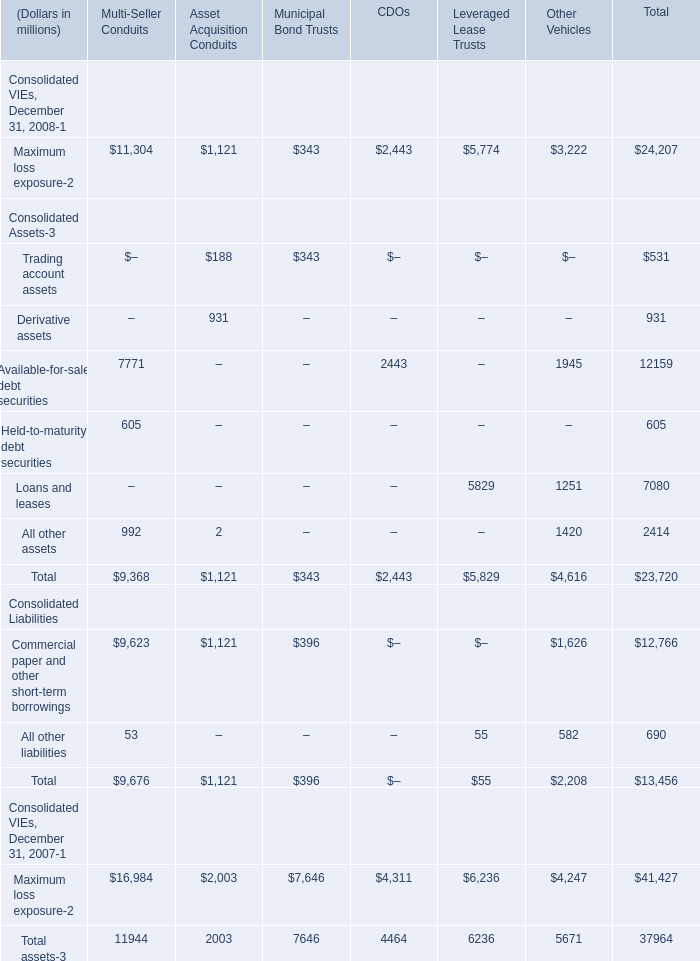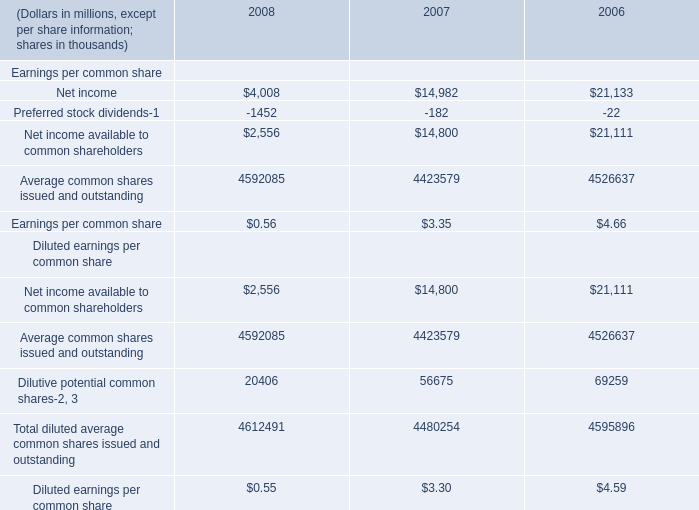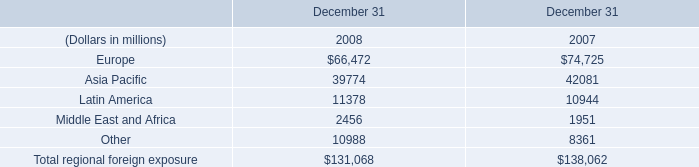What's the average of the Net income for Earnings per common share in the years where aximum loss exposure-2 for Multi-Seller Conduits is greater than 0? (in thousand) 
Computations: ((4008 + 14982) / 2)
Answer: 9495.0. What is the ratio of Net income available to common shareholders in Table 1 to the Asia Pacific in Table 2 in 2007? 
Computations: (14800 / 42081)
Answer: 0.3517. 